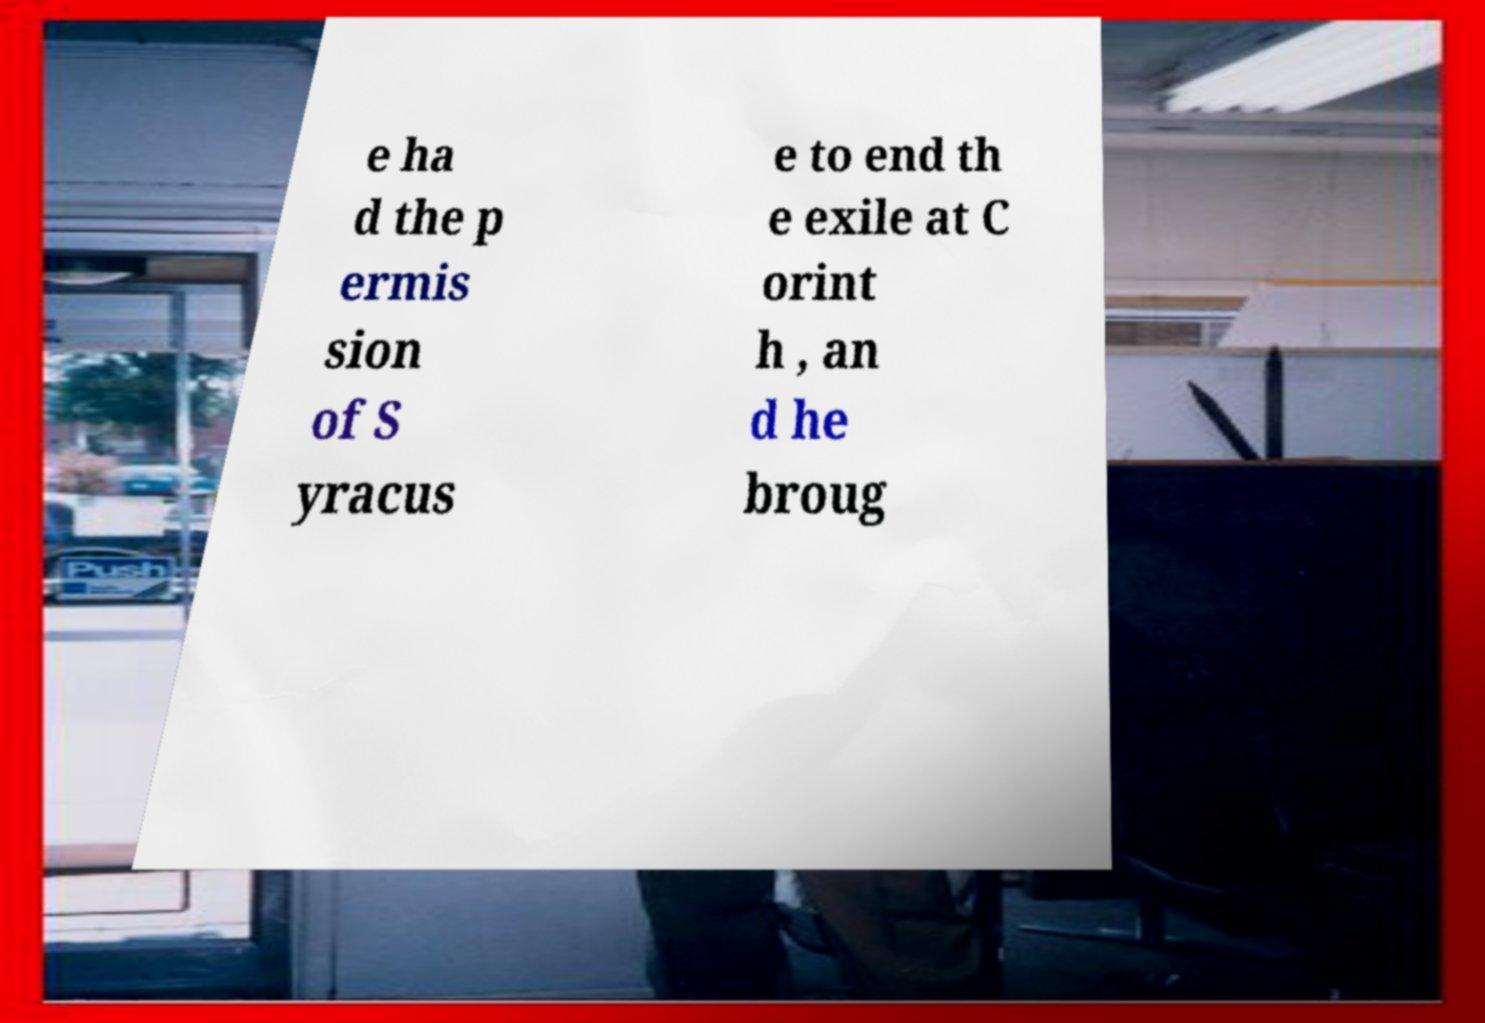Please read and relay the text visible in this image. What does it say? e ha d the p ermis sion of S yracus e to end th e exile at C orint h , an d he broug 